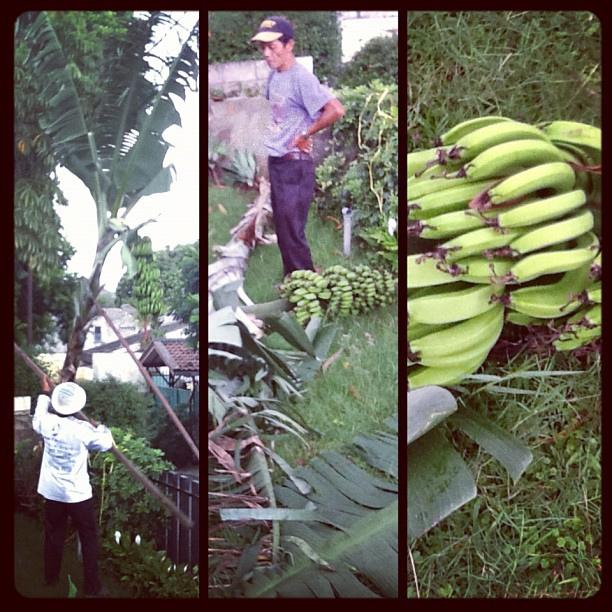What fruit are the people harvesting?
Concise answer only. Bananas. Are those bananas ripe?
Short answer required. No. What kind of vegetable is growing?
Be succinct. Bananas. What kind of fruit tree is this?
Quick response, please. Banana. How many pic panels are there?
Answer briefly. 3. 